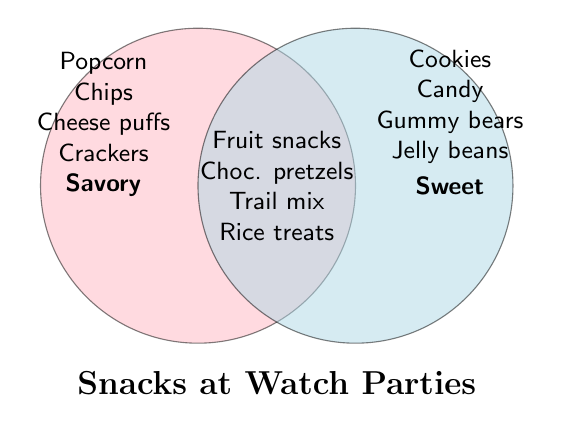What types of snacks fall into both savory and sweet categories? Look at the section where the two circles overlap; these are snacks that are both savory and sweet. The snacks listed there are: Fruit snacks, Chocolate-covered pretzels, Trail mix, and Rice Krispies treats.
Answer: Fruit snacks, Chocolate-covered pretzels, Trail mix, Rice Krispies treats Which category includes popcorn? Examine the left circle labeled "Savory"; popcorn is listed under this category.
Answer: Savory How many types of snacks are considered sweet? Count the items in the right circle labeled "Sweet." There are four items listed.
Answer: Four Is cheese puffs categorized as sweet, savory, or both? Check the left circle labeled "Savory"; cheese puffs are listed under this category.
Answer: Savory Are there more savory or sweet snacks listed? Compare the number of items in the "Savory" circle (4 items) to the number of items in the "Sweet" circle (4 items). Both categories have an equal number of snacks.
Answer: Equal How many snack types fall into both savory and sweet categories? Count the number of items in the overlapping section of the circles; there are four items listed.
Answer: Four Which category includes the most snacks that are savory but not sweet? Check the left circle labeled "Savory" and count the items only in that circle (excluding the overlap). There are four items listed: Popcorn, Chips, Cheese puffs, and Crackers.
Answer: Four Do any snacks fall into neither savory nor sweet categories? All sections of the diagram have been considered, and every snack listed falls into either one of the circles or the overlapping section. Hence, no snacks fall outside the categories.
Answer: No Name two sweet snacks listed in the diagram. Check the right circle labeled "Sweet" for sweet snacks. Examples include Cookies and Candy.
Answer: Cookies, Candy What savory snacks are not also classified as sweet? Look at the items in the "Savory" circle that do not appear in the overlapping section (i.e., Popcorn, Chips, Cheese puffs, Crackers).
Answer: Popcorn, Chips, Cheese puffs, Crackers 